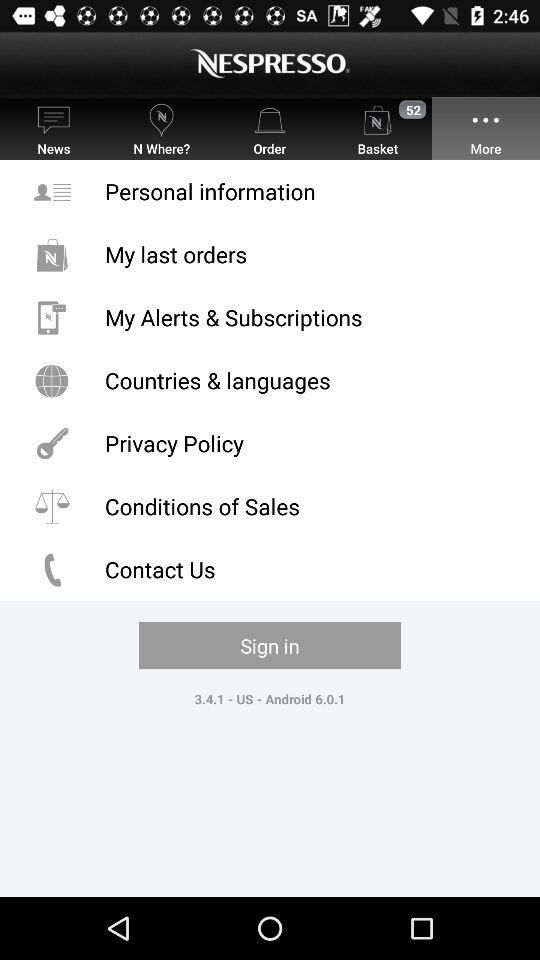What is the version of the "NESPRESSO" app? The version of the "NESPRESSO" app is 3.4.1. 